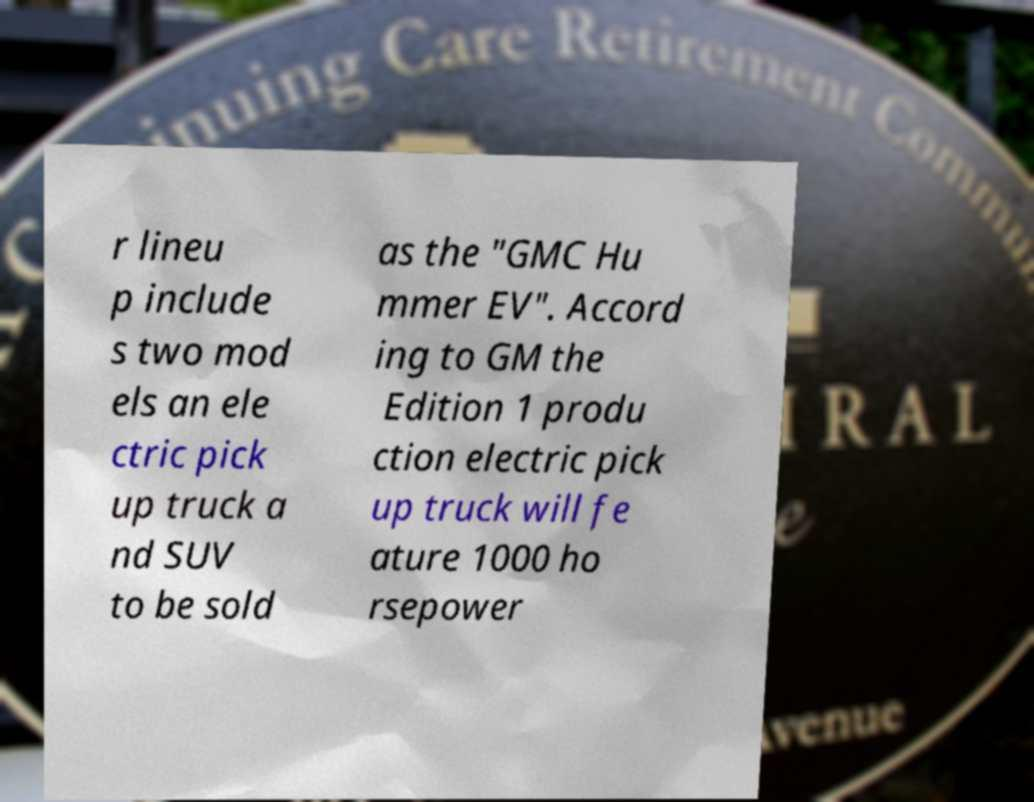There's text embedded in this image that I need extracted. Can you transcribe it verbatim? r lineu p include s two mod els an ele ctric pick up truck a nd SUV to be sold as the "GMC Hu mmer EV". Accord ing to GM the Edition 1 produ ction electric pick up truck will fe ature 1000 ho rsepower 